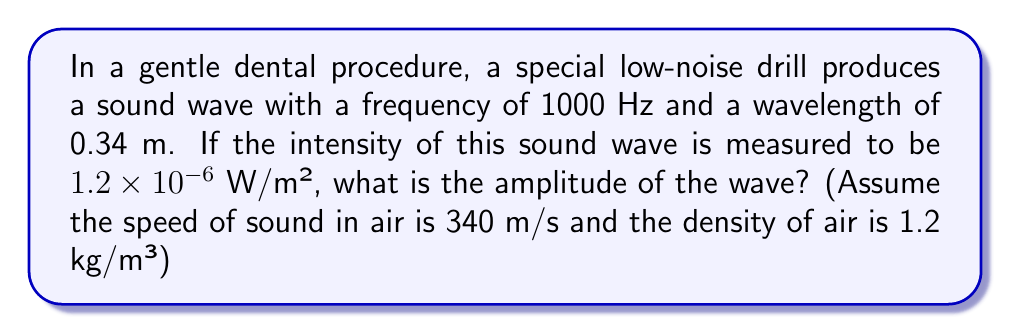Provide a solution to this math problem. Let's approach this step-by-step:

1) First, we need to recall the relationship between intensity (I), amplitude (A), and angular frequency (ω) for a sound wave:

   $I = \frac{1}{2} \rho v \omega^2 A^2$

   Where ρ is the density of the medium and v is the speed of sound.

2) We know:
   - Intensity (I) = $1.2 \times 10^{-6}$ W/m²
   - Frequency (f) = 1000 Hz
   - Wavelength (λ) = 0.34 m
   - Speed of sound (v) = 340 m/s
   - Density of air (ρ) = 1.2 kg/m³

3) We need to calculate the angular frequency (ω):
   $\omega = 2\pi f = 2\pi(1000) = 2000\pi$ rad/s

4) Now, let's substitute these values into our intensity equation:

   $1.2 \times 10^{-6} = \frac{1}{2}(1.2)(340)(2000\pi)^2 A^2$

5) Simplify:
   $1.2 \times 10^{-6} = 8.13 \times 10^9 \pi^2 A^2$

6) Solve for A:
   $A^2 = \frac{1.2 \times 10^{-6}}{8.13 \times 10^9 \pi^2}$

   $A = \sqrt{\frac{1.2 \times 10^{-6}}{8.13 \times 10^9 \pi^2}}$

7) Calculate:
   $A \approx 1.92 \times 10^{-8}$ m

This amplitude is very small, which is consistent with a gentle, low-noise dental procedure.
Answer: $1.92 \times 10^{-8}$ m 